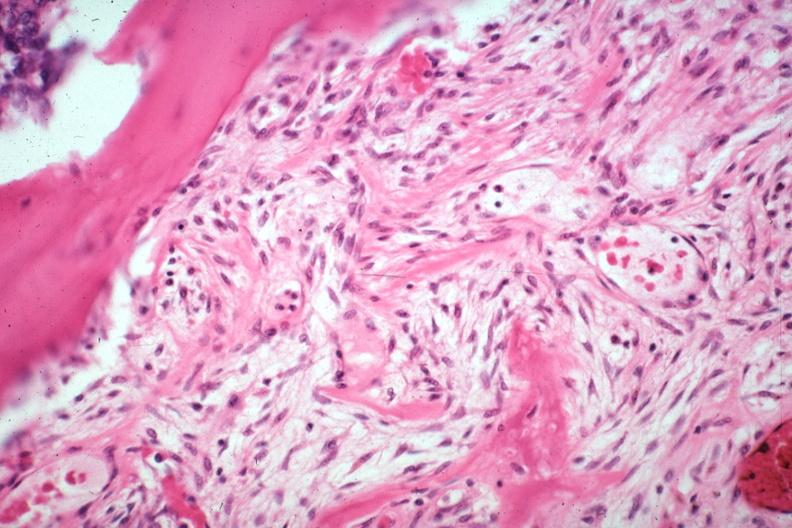how is tumor induced new bone formation large myofibroblastic osteoblastic cells in stroma?
Answer the question using a single word or phrase. Focus of osteoid case of 8 year survival breast intraductal papillary adenocarcinoma 